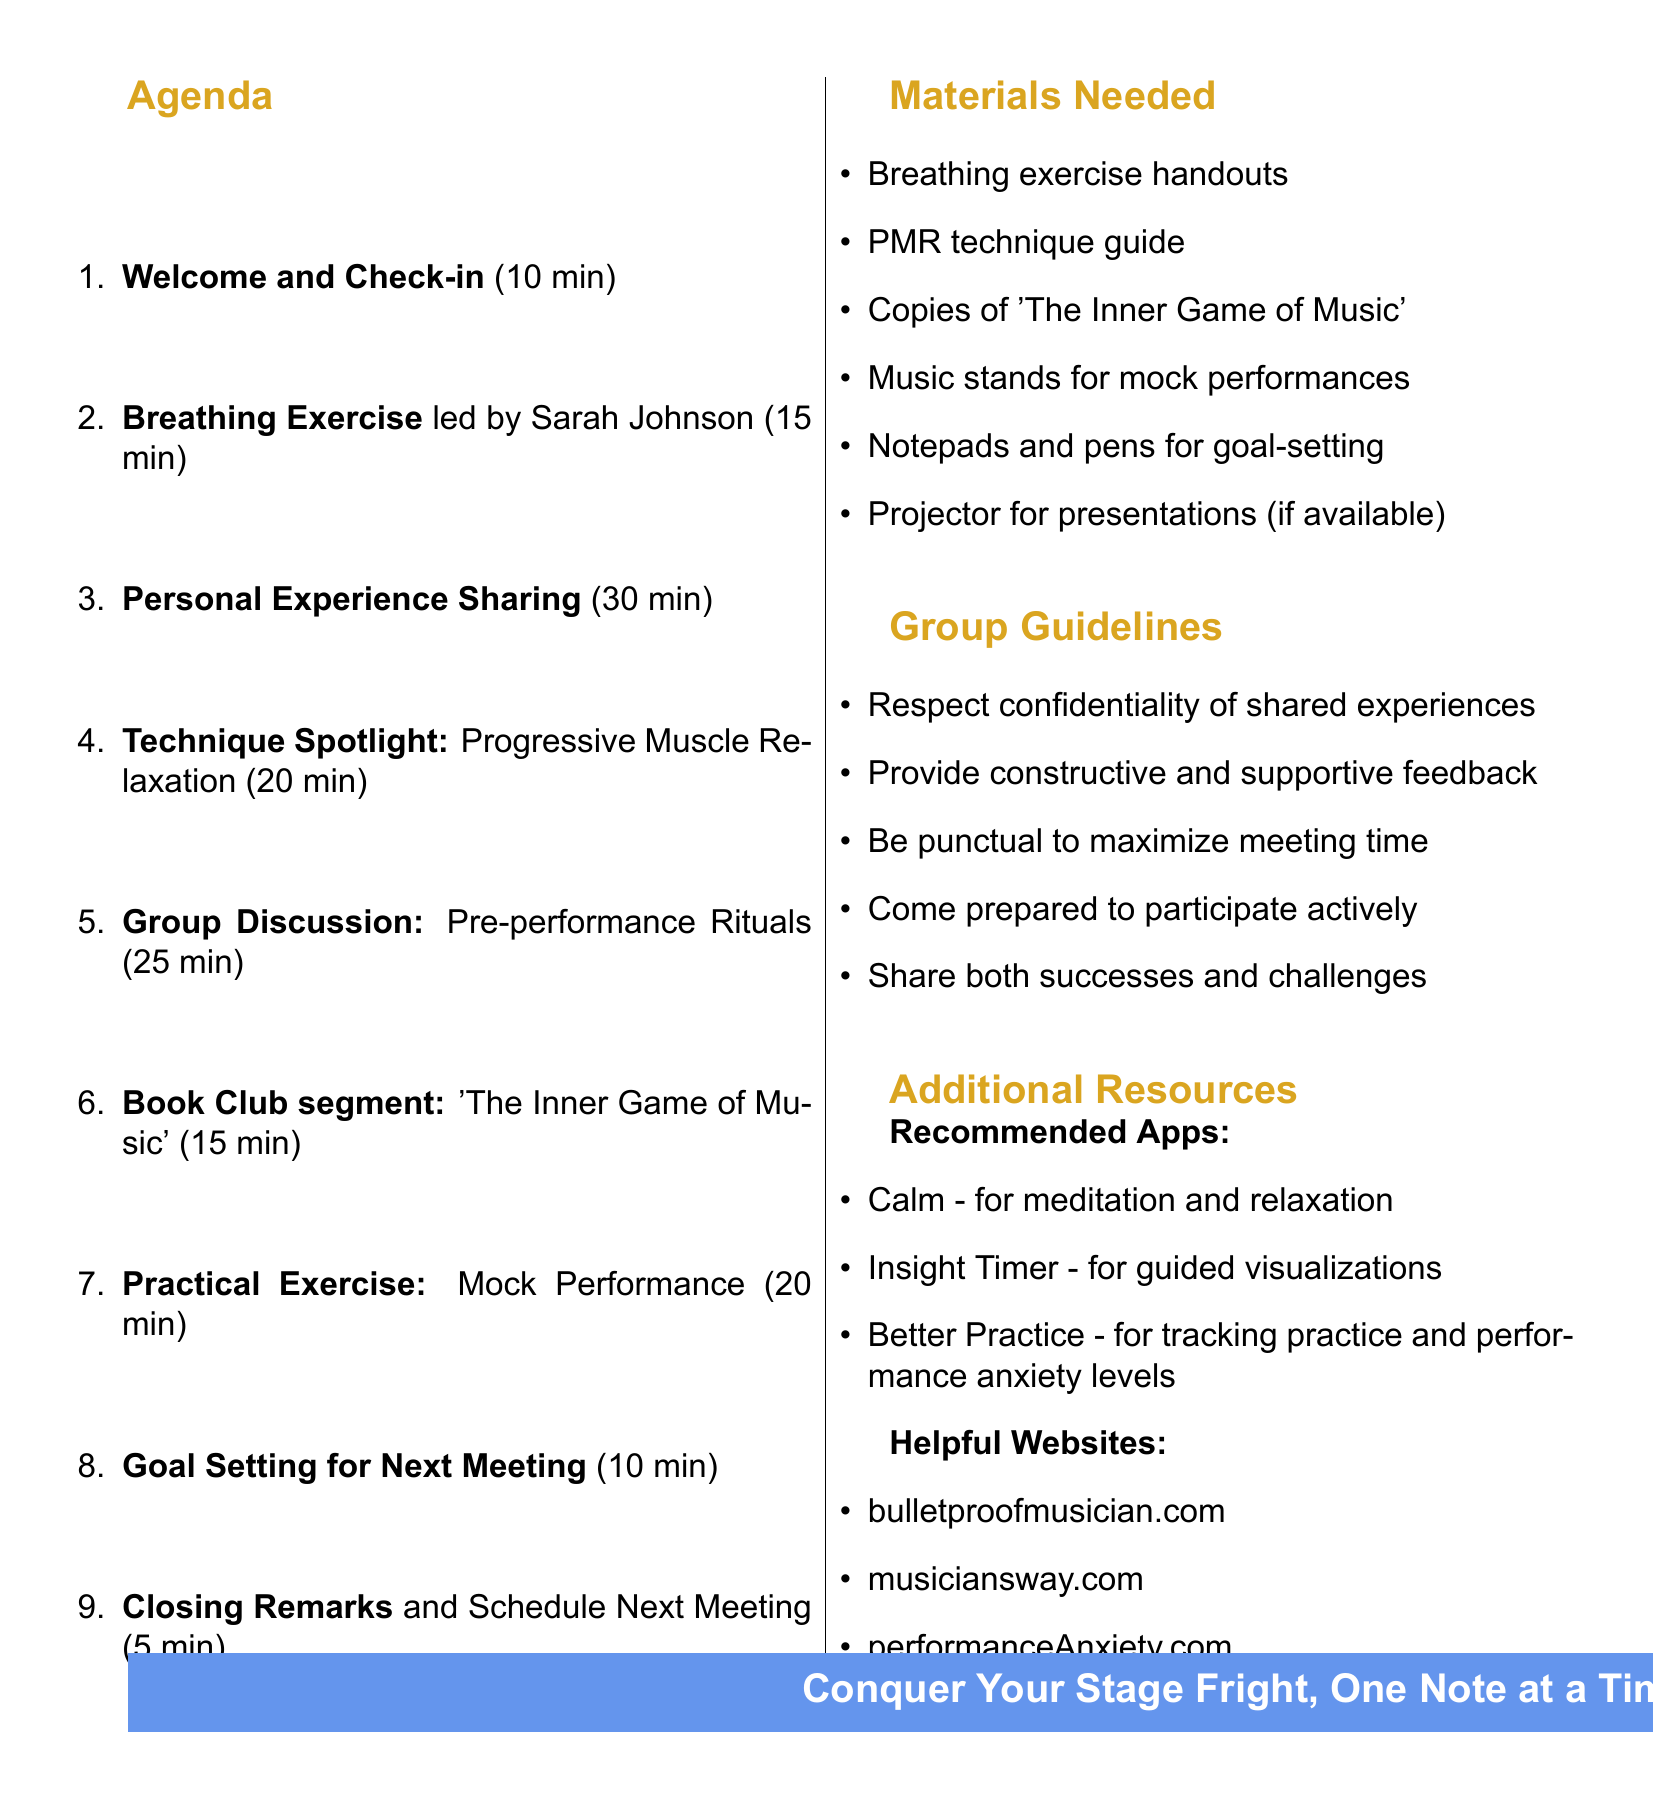What is the title of the meeting? The title of the meeting is explicitly stated in the document.
Answer: Bi-weekly Performance Anxiety Support Group When will the meeting take place? The date and time are mentioned clearly in the document.
Answer: Every other Thursday at 7:00 PM How long is the Personal Experience Sharing segment? The duration of this segment is provided as part of the agenda items.
Answer: 30 minutes Who is leading the breathing exercise? The document specifies who will lead the breathing exercise during the meeting.
Answer: Sarah Johnson What is one of the recommended apps for meditation? The document lists several apps, one can be picked from that list.
Answer: Calm What is the purpose of the Mock Performance exercise? The document provides a brief description of this exercise's intent.
Answer: Supportive feedback How many minutes are allocated to Closing Remarks? The duration for this agenda item is listed directly.
Answer: 5 minutes What is one of the group guidelines? Multiple guidelines are provided; one can be chosen for simplicity.
Answer: Respect confidentiality of shared experiences What book is discussed during the Book Club segment? The document specifically mentions the book being talked about.
Answer: The Inner Game of Music 